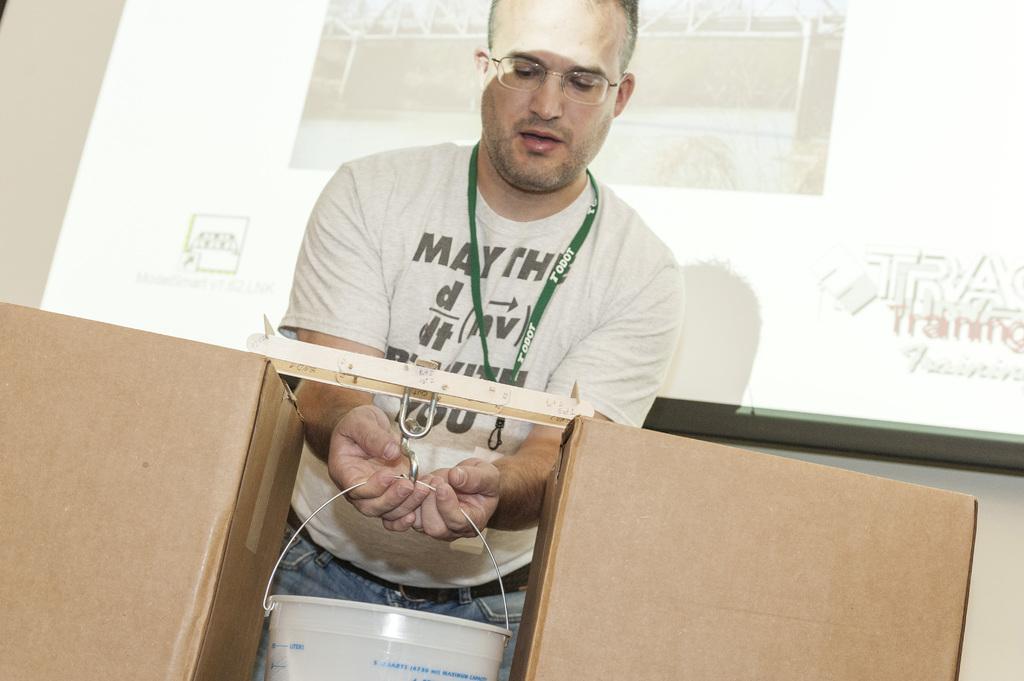Please provide a concise description of this image. In this picture, we see the man in white T-shirt is hanging the white bucket to the hook. He is wearing the spectacles. Beside that, we see brown color boxes. Behind him, we see the projector screen which is displaying something. On the left side, we see a white wall. 